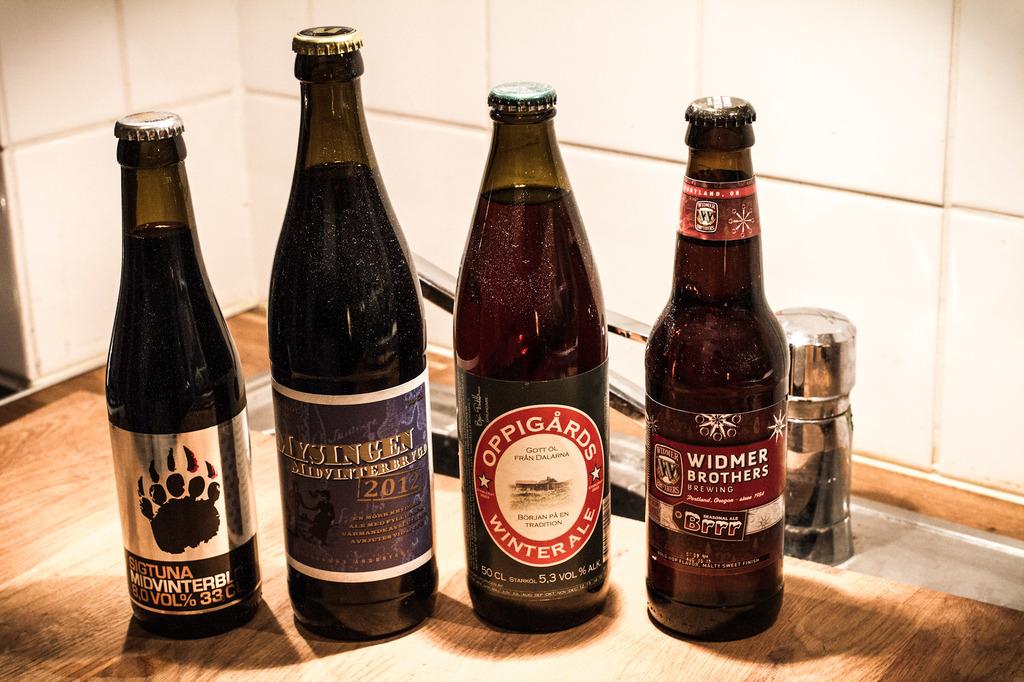What brand is the left beer?
Provide a succinct answer. Sigtuna. 